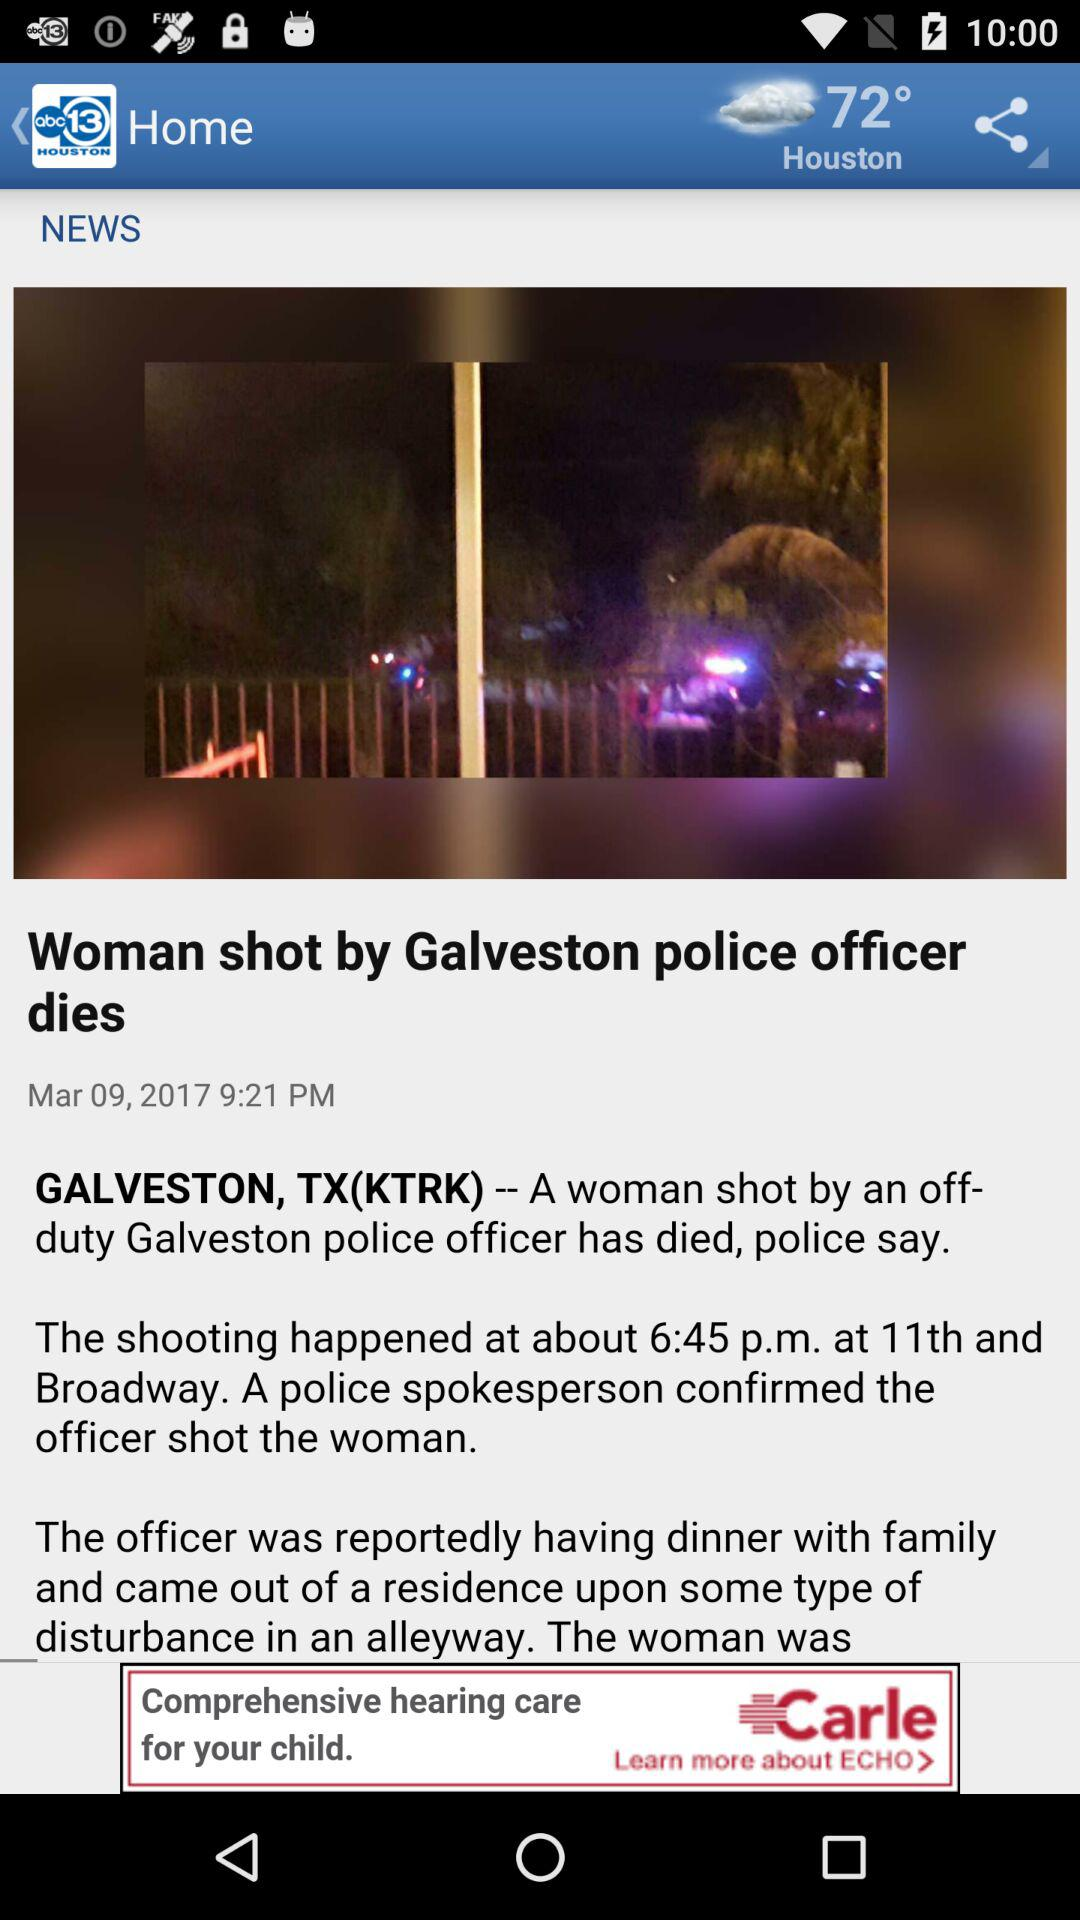What is the television station name? The television station name is "KTRK-TV". 